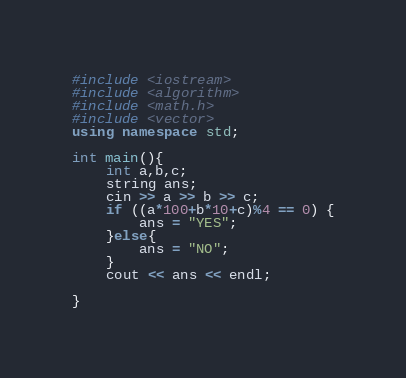Convert code to text. <code><loc_0><loc_0><loc_500><loc_500><_C++_>#include <iostream>
#include <algorithm>
#include <math.h>
#include <vector>
using namespace std;

int main(){
    int a,b,c;
    string ans;
    cin >> a >> b >> c;
    if ((a*100+b*10+c)%4 == 0) {
        ans = "YES";
    }else{
        ans = "NO";
    }
    cout << ans << endl;
    
}</code> 